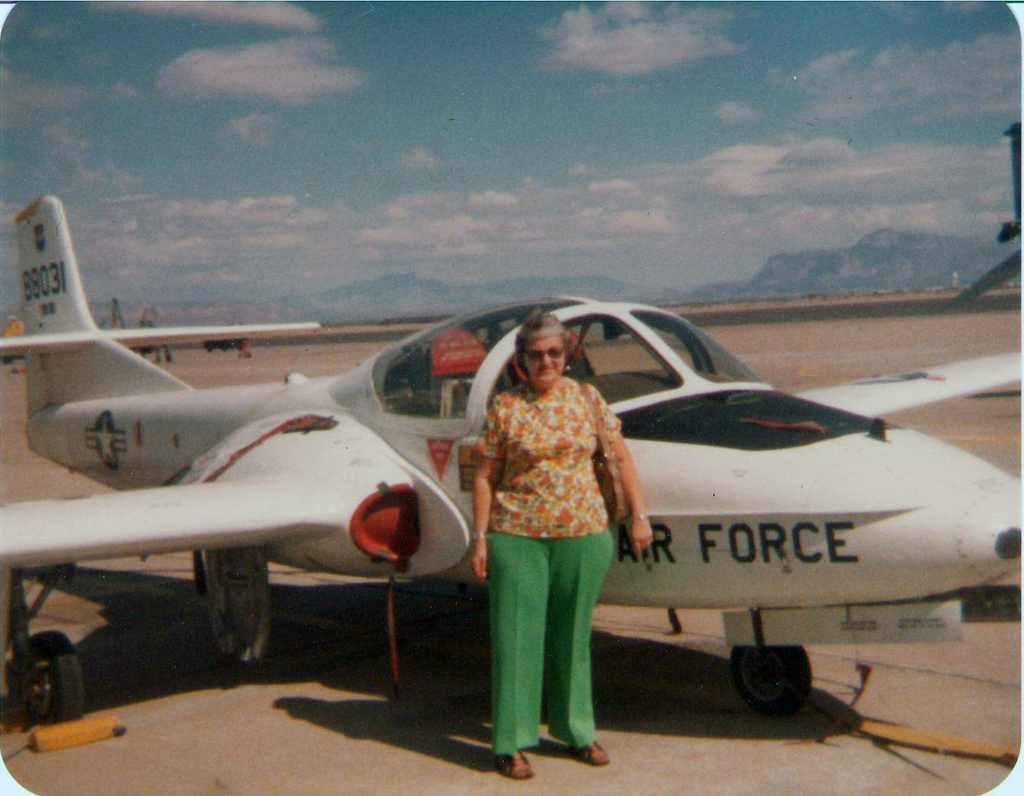What historical significance might the aircraft in the image hold? The aircraft shown is a T-37 Tweet, a jet trainer used by the U.S. Air Force primarily for training pilots from the 1950s through the early 2000s. It played a crucial role in preparing thousands of pilots for more advanced aircraft, reflecting its vital position in military aviation history. 